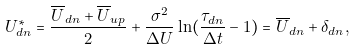<formula> <loc_0><loc_0><loc_500><loc_500>U ^ { * } _ { d n } = \frac { \overline { U } _ { d n } + \overline { U } _ { u p } } { 2 } + \frac { \sigma ^ { 2 } } { \Delta U } \ln ( \frac { \tau _ { d n } } { \Delta t } - 1 ) = \overline { U } _ { d n } + \delta _ { d n } ,</formula> 